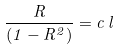<formula> <loc_0><loc_0><loc_500><loc_500>\frac { R } { ( 1 - R ^ { 2 } ) } = c \, l</formula> 